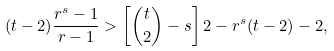<formula> <loc_0><loc_0><loc_500><loc_500>( t - 2 ) \frac { r ^ { s } - 1 } { r - 1 } > \left [ { t \choose 2 } - s \right ] 2 - r ^ { s } ( t - 2 ) - 2 ,</formula> 